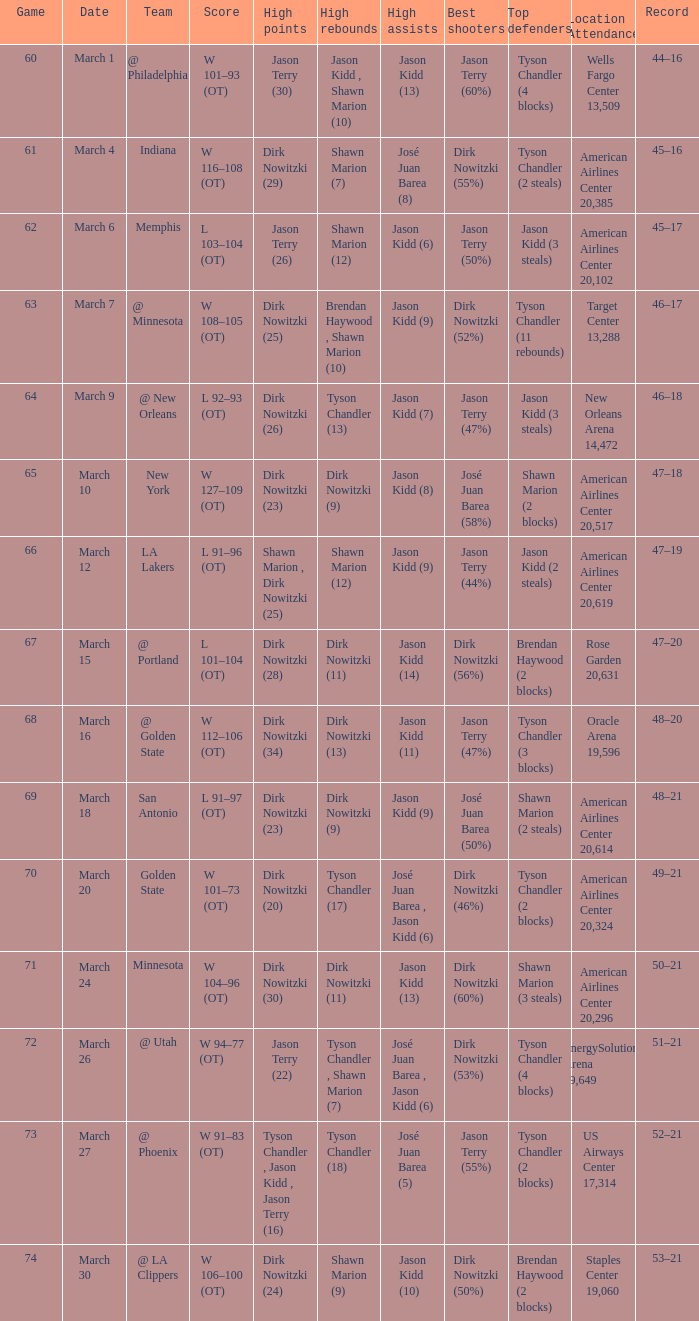Name the high assists for  l 103–104 (ot) Jason Kidd (6). Can you parse all the data within this table? {'header': ['Game', 'Date', 'Team', 'Score', 'High points', 'High rebounds', 'High assists', 'Best shooters', 'Top defenders', 'Location Attendance', 'Record'], 'rows': [['60', 'March 1', '@ Philadelphia', 'W 101–93 (OT)', 'Jason Terry (30)', 'Jason Kidd , Shawn Marion (10)', 'Jason Kidd (13)', 'Jason Terry (60%)', 'Tyson Chandler (4 blocks)', 'Wells Fargo Center 13,509', '44–16'], ['61', 'March 4', 'Indiana', 'W 116–108 (OT)', 'Dirk Nowitzki (29)', 'Shawn Marion (7)', 'José Juan Barea (8)', 'Dirk Nowitzki (55%)', 'Tyson Chandler (2 steals)', 'American Airlines Center 20,385', '45–16'], ['62', 'March 6', 'Memphis', 'L 103–104 (OT)', 'Jason Terry (26)', 'Shawn Marion (12)', 'Jason Kidd (6)', 'Jason Terry (50%)', 'Jason Kidd (3 steals)', 'American Airlines Center 20,102', '45–17'], ['63', 'March 7', '@ Minnesota', 'W 108–105 (OT)', 'Dirk Nowitzki (25)', 'Brendan Haywood , Shawn Marion (10)', 'Jason Kidd (9)', 'Dirk Nowitzki (52%)', 'Tyson Chandler (11 rebounds)', 'Target Center 13,288', '46–17'], ['64', 'March 9', '@ New Orleans', 'L 92–93 (OT)', 'Dirk Nowitzki (26)', 'Tyson Chandler (13)', 'Jason Kidd (7)', 'Jason Terry (47%)', 'Jason Kidd (3 steals)', 'New Orleans Arena 14,472', '46–18'], ['65', 'March 10', 'New York', 'W 127–109 (OT)', 'Dirk Nowitzki (23)', 'Dirk Nowitzki (9)', 'Jason Kidd (8)', 'José Juan Barea (58%)', 'Shawn Marion (2 blocks)', 'American Airlines Center 20,517', '47–18'], ['66', 'March 12', 'LA Lakers', 'L 91–96 (OT)', 'Shawn Marion , Dirk Nowitzki (25)', 'Shawn Marion (12)', 'Jason Kidd (9)', 'Jason Terry (44%)', 'Jason Kidd (2 steals)', 'American Airlines Center 20,619', '47–19'], ['67', 'March 15', '@ Portland', 'L 101–104 (OT)', 'Dirk Nowitzki (28)', 'Dirk Nowitzki (11)', 'Jason Kidd (14)', 'Dirk Nowitzki (56%)', 'Brendan Haywood (2 blocks)', 'Rose Garden 20,631', '47–20'], ['68', 'March 16', '@ Golden State', 'W 112–106 (OT)', 'Dirk Nowitzki (34)', 'Dirk Nowitzki (13)', 'Jason Kidd (11)', 'Jason Terry (47%)', 'Tyson Chandler (3 blocks)', 'Oracle Arena 19,596', '48–20'], ['69', 'March 18', 'San Antonio', 'L 91–97 (OT)', 'Dirk Nowitzki (23)', 'Dirk Nowitzki (9)', 'Jason Kidd (9)', 'José Juan Barea (50%)', 'Shawn Marion (2 steals)', 'American Airlines Center 20,614', '48–21'], ['70', 'March 20', 'Golden State', 'W 101–73 (OT)', 'Dirk Nowitzki (20)', 'Tyson Chandler (17)', 'José Juan Barea , Jason Kidd (6)', 'Dirk Nowitzki (46%)', 'Tyson Chandler (2 blocks)', 'American Airlines Center 20,324', '49–21'], ['71', 'March 24', 'Minnesota', 'W 104–96 (OT)', 'Dirk Nowitzki (30)', 'Dirk Nowitzki (11)', 'Jason Kidd (13)', 'Dirk Nowitzki (60%)', 'Shawn Marion (3 steals)', 'American Airlines Center 20,296', '50–21'], ['72', 'March 26', '@ Utah', 'W 94–77 (OT)', 'Jason Terry (22)', 'Tyson Chandler , Shawn Marion (7)', 'José Juan Barea , Jason Kidd (6)', 'Dirk Nowitzki (53%)', 'Tyson Chandler (4 blocks)', 'EnergySolutions Arena 19,649', '51–21'], ['73', 'March 27', '@ Phoenix', 'W 91–83 (OT)', 'Tyson Chandler , Jason Kidd , Jason Terry (16)', 'Tyson Chandler (18)', 'José Juan Barea (5)', 'Jason Terry (55%)', 'Tyson Chandler (2 blocks)', 'US Airways Center 17,314', '52–21'], ['74', 'March 30', '@ LA Clippers', 'W 106–100 (OT)', 'Dirk Nowitzki (24)', 'Shawn Marion (9)', 'Jason Kidd (10)', 'Dirk Nowitzki (50%)', 'Brendan Haywood (2 blocks)', 'Staples Center 19,060', '53–21']]} 